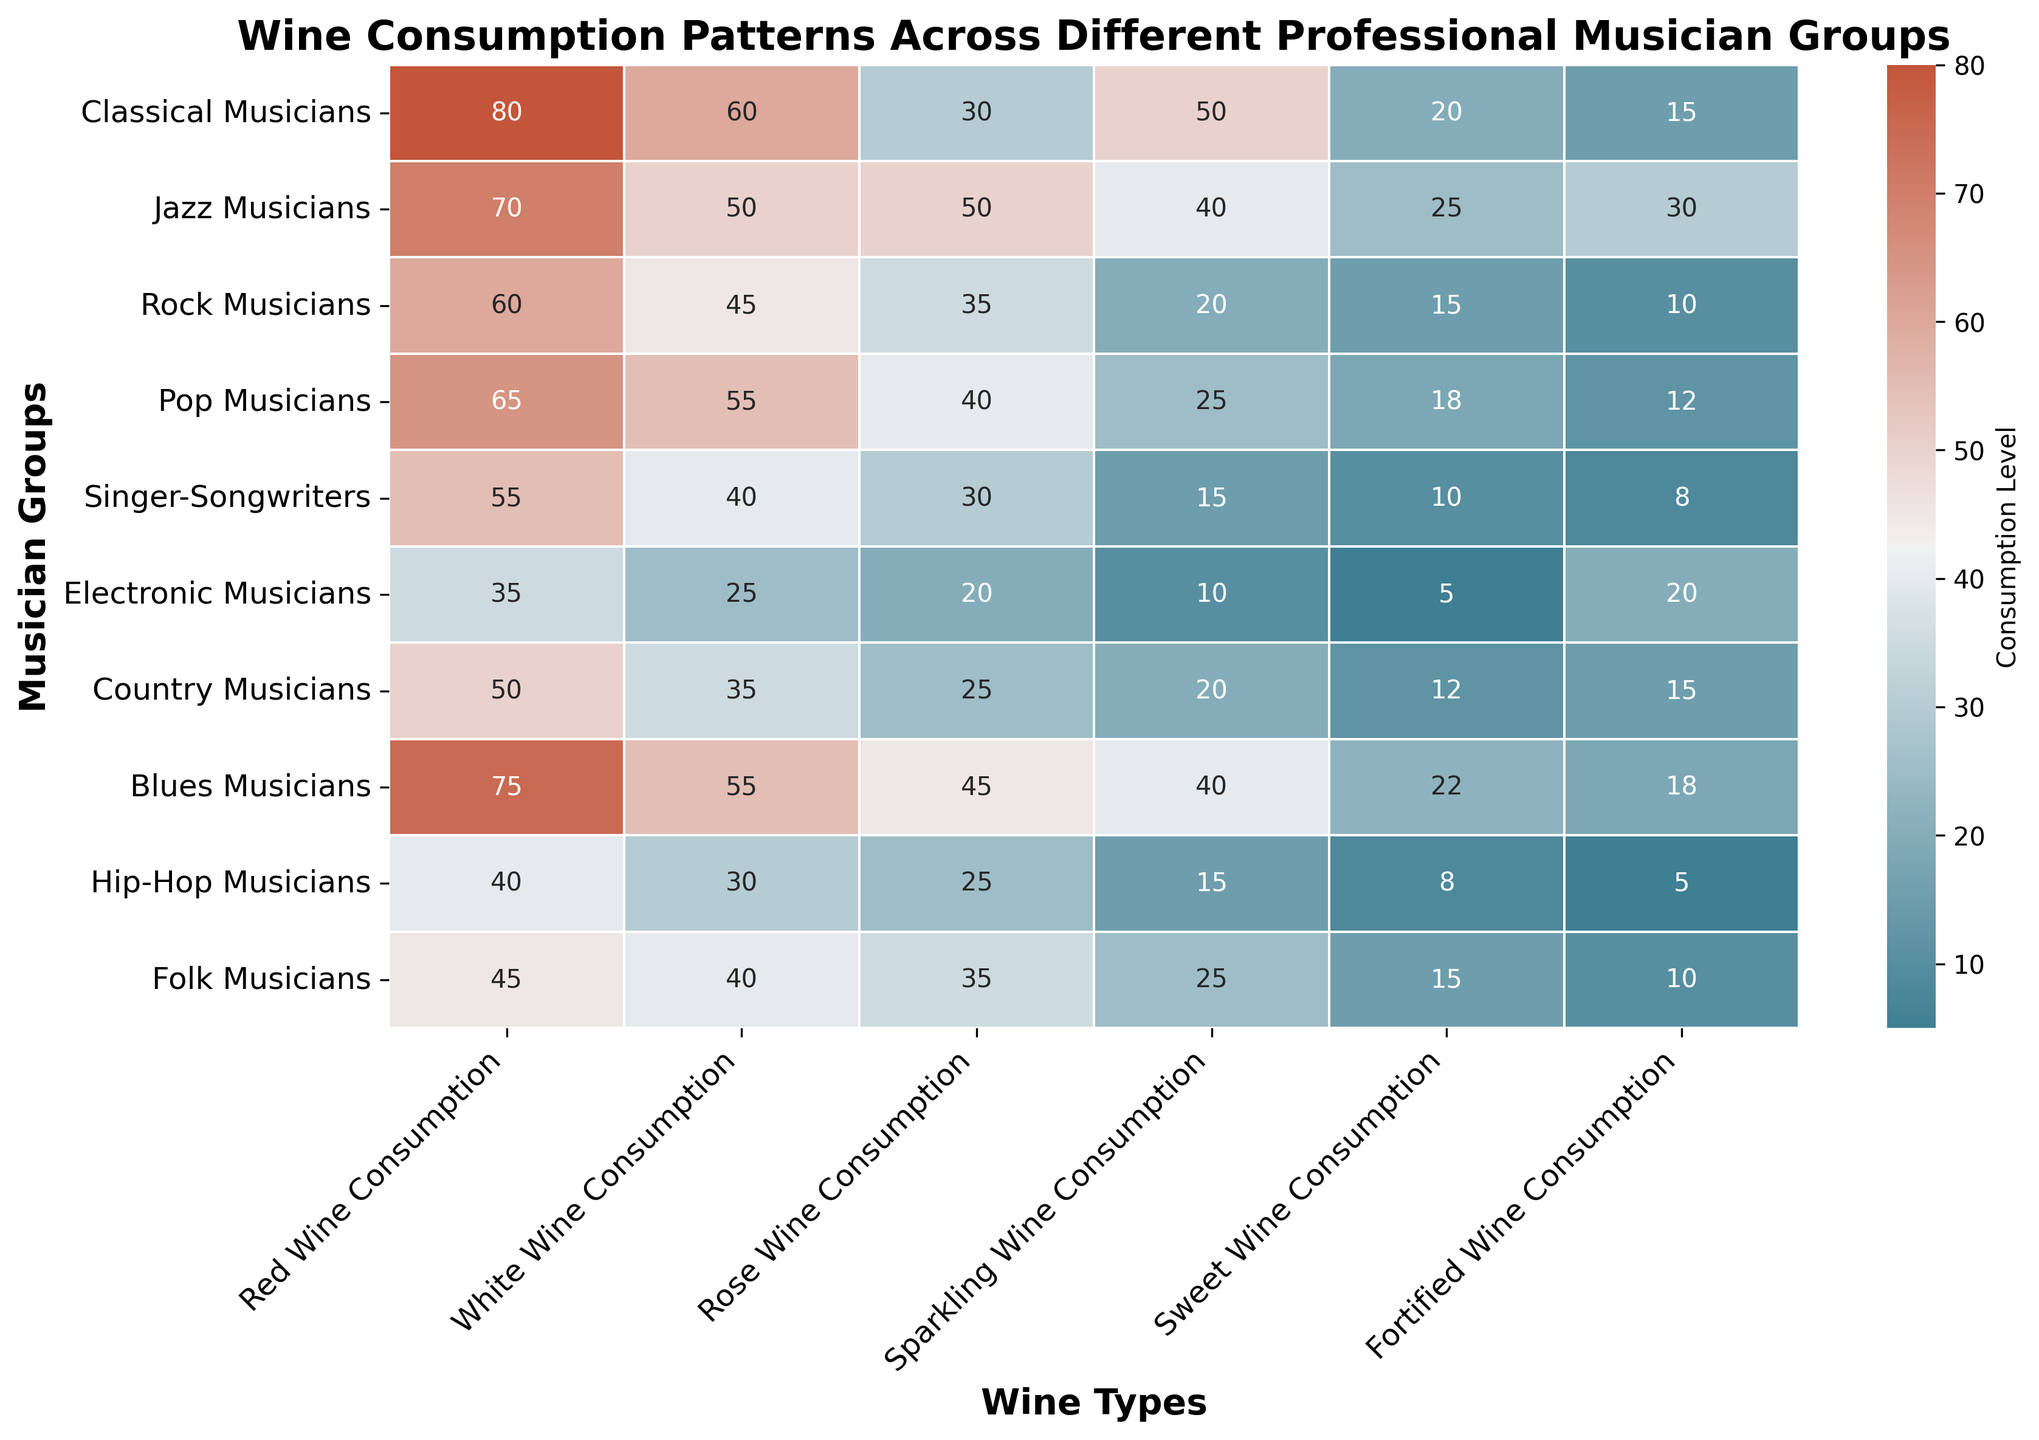Which musician group has the highest red wine consumption? The heatmap shows the intensity of red color as higher consumption levels, and the numerical annotation reveals that Classical Musicians have the highest red wine consumption at 80.
Answer: Classical Musicians How does the white wine consumption of Jazz Musicians compare to Classical Musicians? By examining the heatmap, the white wine consumption for Jazz Musicians is 50, whereas for Classical Musicians it is 60. Jazz Musicians consume less white wine.
Answer: less What is the total wine consumption of Pop Musicians? Summing up the wine consumption for Pop Musicians across all types: 65 (Red) + 55 (White) + 40 (Rosé) + 25 (Sparkling) + 18 (Sweet) + 12 (Fortified) = 215.
Answer: 215 Which musician groups consume more than 20 units of sweet wine? The heatmap indicates that only Jazz Musicians (25) and Blues Musicians (22) consume more than 20 units of sweet wine.
Answer: Jazz Musicians, Blues Musicians What is the difference in fortified wine consumption between Hip-Hop and Electronic Musicians? Hip-Hop Musicians consume 5 units, while Electronic Musicians consume 20 units of fortified wine. The difference is 20 - 5 = 15 units.
Answer: 15 units Which wine type does Rock Musicians consume the most? For Rock Musicians, the highest consumption number on the heatmap corresponds to Red Wine at 60.
Answer: Red Wine Compare the total consumption of all wine types between Classical Musicians and Folk Musicians. Adding up all consumption values for Classical Musicians: 80 + 60 + 30 + 50 + 20 + 15 = 255; and for Folk Musicians: 45 + 40 + 35 + 25 + 15 + 10 = 170. Classical Musicians have a higher total consumption.
Answer: Classical Musicians Which wine type has the highest overall consumption across all musician groups? Summing up the consumption for each wine type: Red Wine = 80+70+60+65+55+35+50+75+40+45 = 575; White Wine = 60+50+45+55+40+25+35+55+30+40 = 435; Rosé Wine = 30+50+35+40+30+20+25+45+25+35 = 335; Sparkling Wine = 50+40+20+25+15+10+20+40+15+25 = 260; Sweet Wine = 20+25+15+18+10+5+12+22+8+15 = 150; Fortified Wine = 15+30+10+12+8+20+15+18+5+10 = 143. Red Wine has the highest overall consumption.
Answer: Red Wine What is the average rose wine consumption across the musician groups who consume more than 30 units of it? Groups consuming more than 30 units of rosé wine: Jazz Musicians (50), Rock Musicians (35), Pop Musicians (40), Blues Musicians (45), and Folk Musicians (35). The average is (50+35+40+45+35) / 5 = 41.
Answer: 41 Which two musician groups have the most similar total red and white wine consumption? Adding red and white wine consumption: Classical Musicians = 80+60=140, Jazz Musicians = 70+50=120, Rock Musicians = 60+45=105, Pop Musicians = 65+55=120, Singer-Songwriters = 55+40=95, Electronic Musicians = 35+25=60, Country Musicians = 50+35=85, Blues Musicians = 75+55=130, Hip-Hop Musicians = 40+30=70, Folk Musicians = 45+40=85. Jazz and Pop Musicians both have a sum of 120.
Answer: Jazz Musicians, Pop Musicians 